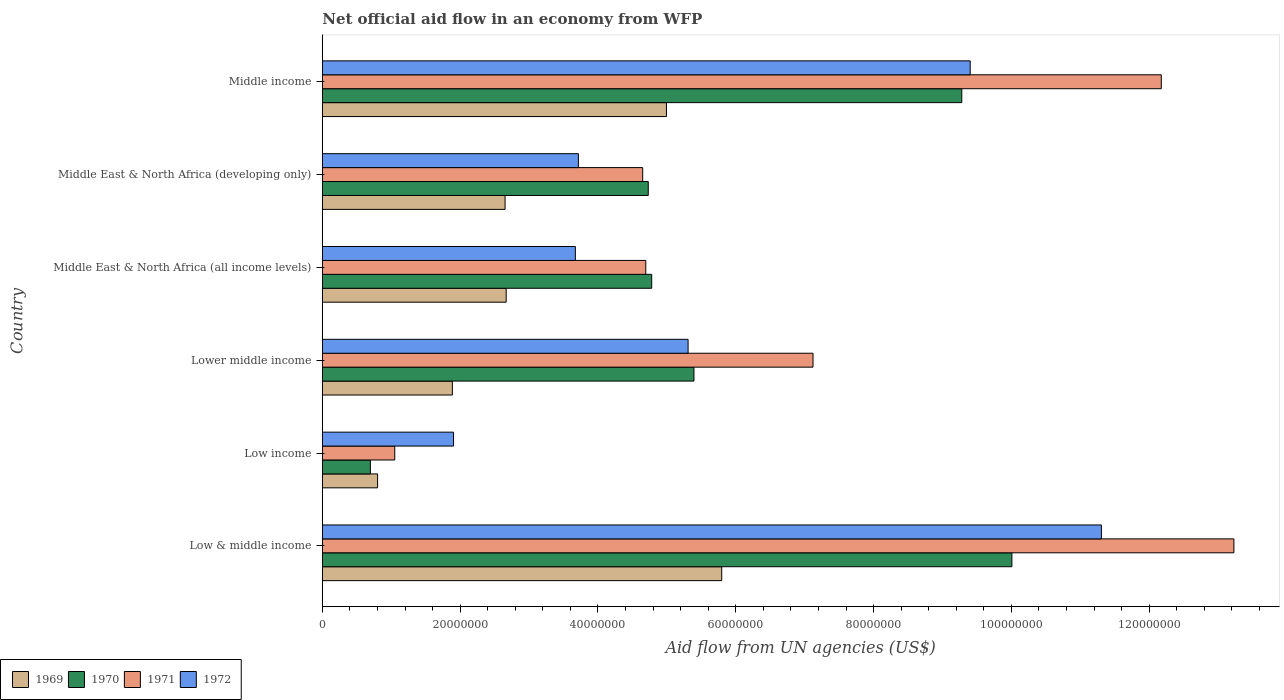How many different coloured bars are there?
Ensure brevity in your answer.  4. Are the number of bars on each tick of the Y-axis equal?
Make the answer very short. Yes. What is the net official aid flow in 1970 in Middle East & North Africa (all income levels)?
Keep it short and to the point. 4.78e+07. Across all countries, what is the maximum net official aid flow in 1972?
Provide a succinct answer. 1.13e+08. Across all countries, what is the minimum net official aid flow in 1970?
Give a very brief answer. 6.97e+06. In which country was the net official aid flow in 1971 maximum?
Provide a short and direct response. Low & middle income. In which country was the net official aid flow in 1972 minimum?
Ensure brevity in your answer.  Low income. What is the total net official aid flow in 1969 in the graph?
Your response must be concise. 1.88e+08. What is the difference between the net official aid flow in 1969 in Low & middle income and that in Low income?
Ensure brevity in your answer.  4.99e+07. What is the difference between the net official aid flow in 1972 in Middle income and the net official aid flow in 1970 in Low income?
Offer a very short reply. 8.70e+07. What is the average net official aid flow in 1972 per country?
Your response must be concise. 5.88e+07. What is the difference between the net official aid flow in 1972 and net official aid flow in 1971 in Middle East & North Africa (developing only)?
Ensure brevity in your answer.  -9.33e+06. What is the ratio of the net official aid flow in 1971 in Middle East & North Africa (all income levels) to that in Middle East & North Africa (developing only)?
Offer a terse response. 1.01. What is the difference between the highest and the second highest net official aid flow in 1972?
Your answer should be compact. 1.90e+07. What is the difference between the highest and the lowest net official aid flow in 1972?
Ensure brevity in your answer.  9.40e+07. Is the sum of the net official aid flow in 1972 in Low & middle income and Middle East & North Africa (all income levels) greater than the maximum net official aid flow in 1970 across all countries?
Keep it short and to the point. Yes. Is it the case that in every country, the sum of the net official aid flow in 1972 and net official aid flow in 1970 is greater than the sum of net official aid flow in 1971 and net official aid flow in 1969?
Offer a terse response. No. What does the 1st bar from the top in Low & middle income represents?
Offer a very short reply. 1972. What does the 3rd bar from the bottom in Lower middle income represents?
Provide a succinct answer. 1971. Is it the case that in every country, the sum of the net official aid flow in 1969 and net official aid flow in 1972 is greater than the net official aid flow in 1971?
Provide a short and direct response. Yes. How many countries are there in the graph?
Give a very brief answer. 6. Are the values on the major ticks of X-axis written in scientific E-notation?
Provide a succinct answer. No. Does the graph contain any zero values?
Make the answer very short. No. Where does the legend appear in the graph?
Ensure brevity in your answer.  Bottom left. How are the legend labels stacked?
Your response must be concise. Horizontal. What is the title of the graph?
Provide a succinct answer. Net official aid flow in an economy from WFP. What is the label or title of the X-axis?
Make the answer very short. Aid flow from UN agencies (US$). What is the label or title of the Y-axis?
Ensure brevity in your answer.  Country. What is the Aid flow from UN agencies (US$) of 1969 in Low & middle income?
Provide a short and direct response. 5.80e+07. What is the Aid flow from UN agencies (US$) of 1970 in Low & middle income?
Your response must be concise. 1.00e+08. What is the Aid flow from UN agencies (US$) in 1971 in Low & middle income?
Give a very brief answer. 1.32e+08. What is the Aid flow from UN agencies (US$) of 1972 in Low & middle income?
Keep it short and to the point. 1.13e+08. What is the Aid flow from UN agencies (US$) of 1969 in Low income?
Your answer should be compact. 8.02e+06. What is the Aid flow from UN agencies (US$) in 1970 in Low income?
Ensure brevity in your answer.  6.97e+06. What is the Aid flow from UN agencies (US$) of 1971 in Low income?
Keep it short and to the point. 1.05e+07. What is the Aid flow from UN agencies (US$) in 1972 in Low income?
Keep it short and to the point. 1.90e+07. What is the Aid flow from UN agencies (US$) in 1969 in Lower middle income?
Offer a terse response. 1.89e+07. What is the Aid flow from UN agencies (US$) in 1970 in Lower middle income?
Keep it short and to the point. 5.39e+07. What is the Aid flow from UN agencies (US$) in 1971 in Lower middle income?
Ensure brevity in your answer.  7.12e+07. What is the Aid flow from UN agencies (US$) of 1972 in Lower middle income?
Provide a succinct answer. 5.31e+07. What is the Aid flow from UN agencies (US$) in 1969 in Middle East & North Africa (all income levels)?
Ensure brevity in your answer.  2.67e+07. What is the Aid flow from UN agencies (US$) in 1970 in Middle East & North Africa (all income levels)?
Your answer should be compact. 4.78e+07. What is the Aid flow from UN agencies (US$) of 1971 in Middle East & North Africa (all income levels)?
Offer a very short reply. 4.69e+07. What is the Aid flow from UN agencies (US$) of 1972 in Middle East & North Africa (all income levels)?
Keep it short and to the point. 3.67e+07. What is the Aid flow from UN agencies (US$) of 1969 in Middle East & North Africa (developing only)?
Give a very brief answer. 2.65e+07. What is the Aid flow from UN agencies (US$) in 1970 in Middle East & North Africa (developing only)?
Provide a succinct answer. 4.73e+07. What is the Aid flow from UN agencies (US$) of 1971 in Middle East & North Africa (developing only)?
Offer a very short reply. 4.65e+07. What is the Aid flow from UN agencies (US$) of 1972 in Middle East & North Africa (developing only)?
Make the answer very short. 3.72e+07. What is the Aid flow from UN agencies (US$) of 1969 in Middle income?
Offer a terse response. 4.99e+07. What is the Aid flow from UN agencies (US$) of 1970 in Middle income?
Give a very brief answer. 9.28e+07. What is the Aid flow from UN agencies (US$) of 1971 in Middle income?
Keep it short and to the point. 1.22e+08. What is the Aid flow from UN agencies (US$) in 1972 in Middle income?
Offer a terse response. 9.40e+07. Across all countries, what is the maximum Aid flow from UN agencies (US$) of 1969?
Keep it short and to the point. 5.80e+07. Across all countries, what is the maximum Aid flow from UN agencies (US$) of 1970?
Your answer should be compact. 1.00e+08. Across all countries, what is the maximum Aid flow from UN agencies (US$) of 1971?
Your answer should be very brief. 1.32e+08. Across all countries, what is the maximum Aid flow from UN agencies (US$) of 1972?
Provide a succinct answer. 1.13e+08. Across all countries, what is the minimum Aid flow from UN agencies (US$) of 1969?
Offer a very short reply. 8.02e+06. Across all countries, what is the minimum Aid flow from UN agencies (US$) of 1970?
Give a very brief answer. 6.97e+06. Across all countries, what is the minimum Aid flow from UN agencies (US$) in 1971?
Your answer should be very brief. 1.05e+07. Across all countries, what is the minimum Aid flow from UN agencies (US$) of 1972?
Provide a short and direct response. 1.90e+07. What is the total Aid flow from UN agencies (US$) of 1969 in the graph?
Keep it short and to the point. 1.88e+08. What is the total Aid flow from UN agencies (US$) of 1970 in the graph?
Your response must be concise. 3.49e+08. What is the total Aid flow from UN agencies (US$) in 1971 in the graph?
Keep it short and to the point. 4.29e+08. What is the total Aid flow from UN agencies (US$) of 1972 in the graph?
Offer a terse response. 3.53e+08. What is the difference between the Aid flow from UN agencies (US$) of 1969 in Low & middle income and that in Low income?
Offer a very short reply. 4.99e+07. What is the difference between the Aid flow from UN agencies (US$) of 1970 in Low & middle income and that in Low income?
Keep it short and to the point. 9.31e+07. What is the difference between the Aid flow from UN agencies (US$) of 1971 in Low & middle income and that in Low income?
Your response must be concise. 1.22e+08. What is the difference between the Aid flow from UN agencies (US$) of 1972 in Low & middle income and that in Low income?
Provide a succinct answer. 9.40e+07. What is the difference between the Aid flow from UN agencies (US$) of 1969 in Low & middle income and that in Lower middle income?
Offer a very short reply. 3.91e+07. What is the difference between the Aid flow from UN agencies (US$) of 1970 in Low & middle income and that in Lower middle income?
Keep it short and to the point. 4.61e+07. What is the difference between the Aid flow from UN agencies (US$) of 1971 in Low & middle income and that in Lower middle income?
Your answer should be compact. 6.11e+07. What is the difference between the Aid flow from UN agencies (US$) in 1972 in Low & middle income and that in Lower middle income?
Your answer should be compact. 6.00e+07. What is the difference between the Aid flow from UN agencies (US$) of 1969 in Low & middle income and that in Middle East & North Africa (all income levels)?
Your answer should be very brief. 3.13e+07. What is the difference between the Aid flow from UN agencies (US$) in 1970 in Low & middle income and that in Middle East & North Africa (all income levels)?
Your response must be concise. 5.23e+07. What is the difference between the Aid flow from UN agencies (US$) in 1971 in Low & middle income and that in Middle East & North Africa (all income levels)?
Ensure brevity in your answer.  8.54e+07. What is the difference between the Aid flow from UN agencies (US$) of 1972 in Low & middle income and that in Middle East & North Africa (all income levels)?
Offer a terse response. 7.63e+07. What is the difference between the Aid flow from UN agencies (US$) in 1969 in Low & middle income and that in Middle East & North Africa (developing only)?
Offer a terse response. 3.14e+07. What is the difference between the Aid flow from UN agencies (US$) in 1970 in Low & middle income and that in Middle East & North Africa (developing only)?
Provide a succinct answer. 5.28e+07. What is the difference between the Aid flow from UN agencies (US$) in 1971 in Low & middle income and that in Middle East & North Africa (developing only)?
Offer a terse response. 8.58e+07. What is the difference between the Aid flow from UN agencies (US$) in 1972 in Low & middle income and that in Middle East & North Africa (developing only)?
Keep it short and to the point. 7.59e+07. What is the difference between the Aid flow from UN agencies (US$) in 1969 in Low & middle income and that in Middle income?
Provide a succinct answer. 8.02e+06. What is the difference between the Aid flow from UN agencies (US$) of 1970 in Low & middle income and that in Middle income?
Keep it short and to the point. 7.27e+06. What is the difference between the Aid flow from UN agencies (US$) in 1971 in Low & middle income and that in Middle income?
Your answer should be compact. 1.05e+07. What is the difference between the Aid flow from UN agencies (US$) in 1972 in Low & middle income and that in Middle income?
Provide a short and direct response. 1.90e+07. What is the difference between the Aid flow from UN agencies (US$) of 1969 in Low income and that in Lower middle income?
Your answer should be very brief. -1.08e+07. What is the difference between the Aid flow from UN agencies (US$) in 1970 in Low income and that in Lower middle income?
Offer a terse response. -4.70e+07. What is the difference between the Aid flow from UN agencies (US$) in 1971 in Low income and that in Lower middle income?
Your answer should be very brief. -6.07e+07. What is the difference between the Aid flow from UN agencies (US$) in 1972 in Low income and that in Lower middle income?
Your response must be concise. -3.40e+07. What is the difference between the Aid flow from UN agencies (US$) in 1969 in Low income and that in Middle East & North Africa (all income levels)?
Offer a terse response. -1.87e+07. What is the difference between the Aid flow from UN agencies (US$) of 1970 in Low income and that in Middle East & North Africa (all income levels)?
Ensure brevity in your answer.  -4.08e+07. What is the difference between the Aid flow from UN agencies (US$) of 1971 in Low income and that in Middle East & North Africa (all income levels)?
Give a very brief answer. -3.64e+07. What is the difference between the Aid flow from UN agencies (US$) of 1972 in Low income and that in Middle East & North Africa (all income levels)?
Provide a succinct answer. -1.77e+07. What is the difference between the Aid flow from UN agencies (US$) of 1969 in Low income and that in Middle East & North Africa (developing only)?
Your response must be concise. -1.85e+07. What is the difference between the Aid flow from UN agencies (US$) of 1970 in Low income and that in Middle East & North Africa (developing only)?
Make the answer very short. -4.03e+07. What is the difference between the Aid flow from UN agencies (US$) in 1971 in Low income and that in Middle East & North Africa (developing only)?
Give a very brief answer. -3.60e+07. What is the difference between the Aid flow from UN agencies (US$) in 1972 in Low income and that in Middle East & North Africa (developing only)?
Keep it short and to the point. -1.81e+07. What is the difference between the Aid flow from UN agencies (US$) in 1969 in Low income and that in Middle income?
Ensure brevity in your answer.  -4.19e+07. What is the difference between the Aid flow from UN agencies (US$) of 1970 in Low income and that in Middle income?
Make the answer very short. -8.58e+07. What is the difference between the Aid flow from UN agencies (US$) of 1971 in Low income and that in Middle income?
Offer a terse response. -1.11e+08. What is the difference between the Aid flow from UN agencies (US$) of 1972 in Low income and that in Middle income?
Offer a terse response. -7.50e+07. What is the difference between the Aid flow from UN agencies (US$) in 1969 in Lower middle income and that in Middle East & North Africa (all income levels)?
Ensure brevity in your answer.  -7.81e+06. What is the difference between the Aid flow from UN agencies (US$) in 1970 in Lower middle income and that in Middle East & North Africa (all income levels)?
Your answer should be very brief. 6.13e+06. What is the difference between the Aid flow from UN agencies (US$) in 1971 in Lower middle income and that in Middle East & North Africa (all income levels)?
Offer a very short reply. 2.43e+07. What is the difference between the Aid flow from UN agencies (US$) of 1972 in Lower middle income and that in Middle East & North Africa (all income levels)?
Offer a terse response. 1.64e+07. What is the difference between the Aid flow from UN agencies (US$) in 1969 in Lower middle income and that in Middle East & North Africa (developing only)?
Provide a short and direct response. -7.65e+06. What is the difference between the Aid flow from UN agencies (US$) of 1970 in Lower middle income and that in Middle East & North Africa (developing only)?
Give a very brief answer. 6.63e+06. What is the difference between the Aid flow from UN agencies (US$) in 1971 in Lower middle income and that in Middle East & North Africa (developing only)?
Your response must be concise. 2.47e+07. What is the difference between the Aid flow from UN agencies (US$) of 1972 in Lower middle income and that in Middle East & North Africa (developing only)?
Provide a succinct answer. 1.59e+07. What is the difference between the Aid flow from UN agencies (US$) in 1969 in Lower middle income and that in Middle income?
Ensure brevity in your answer.  -3.11e+07. What is the difference between the Aid flow from UN agencies (US$) in 1970 in Lower middle income and that in Middle income?
Your answer should be very brief. -3.89e+07. What is the difference between the Aid flow from UN agencies (US$) of 1971 in Lower middle income and that in Middle income?
Offer a very short reply. -5.05e+07. What is the difference between the Aid flow from UN agencies (US$) of 1972 in Lower middle income and that in Middle income?
Give a very brief answer. -4.09e+07. What is the difference between the Aid flow from UN agencies (US$) in 1970 in Middle East & North Africa (all income levels) and that in Middle East & North Africa (developing only)?
Give a very brief answer. 5.00e+05. What is the difference between the Aid flow from UN agencies (US$) in 1971 in Middle East & North Africa (all income levels) and that in Middle East & North Africa (developing only)?
Keep it short and to the point. 4.50e+05. What is the difference between the Aid flow from UN agencies (US$) of 1972 in Middle East & North Africa (all income levels) and that in Middle East & North Africa (developing only)?
Offer a very short reply. -4.40e+05. What is the difference between the Aid flow from UN agencies (US$) in 1969 in Middle East & North Africa (all income levels) and that in Middle income?
Provide a short and direct response. -2.33e+07. What is the difference between the Aid flow from UN agencies (US$) of 1970 in Middle East & North Africa (all income levels) and that in Middle income?
Keep it short and to the point. -4.50e+07. What is the difference between the Aid flow from UN agencies (US$) of 1971 in Middle East & North Africa (all income levels) and that in Middle income?
Your answer should be very brief. -7.48e+07. What is the difference between the Aid flow from UN agencies (US$) of 1972 in Middle East & North Africa (all income levels) and that in Middle income?
Provide a short and direct response. -5.73e+07. What is the difference between the Aid flow from UN agencies (US$) of 1969 in Middle East & North Africa (developing only) and that in Middle income?
Offer a very short reply. -2.34e+07. What is the difference between the Aid flow from UN agencies (US$) in 1970 in Middle East & North Africa (developing only) and that in Middle income?
Make the answer very short. -4.55e+07. What is the difference between the Aid flow from UN agencies (US$) of 1971 in Middle East & North Africa (developing only) and that in Middle income?
Offer a very short reply. -7.53e+07. What is the difference between the Aid flow from UN agencies (US$) in 1972 in Middle East & North Africa (developing only) and that in Middle income?
Your answer should be compact. -5.69e+07. What is the difference between the Aid flow from UN agencies (US$) in 1969 in Low & middle income and the Aid flow from UN agencies (US$) in 1970 in Low income?
Provide a short and direct response. 5.10e+07. What is the difference between the Aid flow from UN agencies (US$) of 1969 in Low & middle income and the Aid flow from UN agencies (US$) of 1971 in Low income?
Your response must be concise. 4.74e+07. What is the difference between the Aid flow from UN agencies (US$) of 1969 in Low & middle income and the Aid flow from UN agencies (US$) of 1972 in Low income?
Provide a succinct answer. 3.89e+07. What is the difference between the Aid flow from UN agencies (US$) in 1970 in Low & middle income and the Aid flow from UN agencies (US$) in 1971 in Low income?
Ensure brevity in your answer.  8.96e+07. What is the difference between the Aid flow from UN agencies (US$) in 1970 in Low & middle income and the Aid flow from UN agencies (US$) in 1972 in Low income?
Your answer should be very brief. 8.10e+07. What is the difference between the Aid flow from UN agencies (US$) in 1971 in Low & middle income and the Aid flow from UN agencies (US$) in 1972 in Low income?
Give a very brief answer. 1.13e+08. What is the difference between the Aid flow from UN agencies (US$) of 1969 in Low & middle income and the Aid flow from UN agencies (US$) of 1970 in Lower middle income?
Make the answer very short. 4.03e+06. What is the difference between the Aid flow from UN agencies (US$) of 1969 in Low & middle income and the Aid flow from UN agencies (US$) of 1971 in Lower middle income?
Offer a terse response. -1.32e+07. What is the difference between the Aid flow from UN agencies (US$) in 1969 in Low & middle income and the Aid flow from UN agencies (US$) in 1972 in Lower middle income?
Your answer should be very brief. 4.88e+06. What is the difference between the Aid flow from UN agencies (US$) of 1970 in Low & middle income and the Aid flow from UN agencies (US$) of 1971 in Lower middle income?
Keep it short and to the point. 2.89e+07. What is the difference between the Aid flow from UN agencies (US$) of 1970 in Low & middle income and the Aid flow from UN agencies (US$) of 1972 in Lower middle income?
Your response must be concise. 4.70e+07. What is the difference between the Aid flow from UN agencies (US$) in 1971 in Low & middle income and the Aid flow from UN agencies (US$) in 1972 in Lower middle income?
Offer a very short reply. 7.92e+07. What is the difference between the Aid flow from UN agencies (US$) of 1969 in Low & middle income and the Aid flow from UN agencies (US$) of 1970 in Middle East & North Africa (all income levels)?
Your answer should be very brief. 1.02e+07. What is the difference between the Aid flow from UN agencies (US$) in 1969 in Low & middle income and the Aid flow from UN agencies (US$) in 1971 in Middle East & North Africa (all income levels)?
Your answer should be very brief. 1.10e+07. What is the difference between the Aid flow from UN agencies (US$) in 1969 in Low & middle income and the Aid flow from UN agencies (US$) in 1972 in Middle East & North Africa (all income levels)?
Your response must be concise. 2.12e+07. What is the difference between the Aid flow from UN agencies (US$) in 1970 in Low & middle income and the Aid flow from UN agencies (US$) in 1971 in Middle East & North Africa (all income levels)?
Keep it short and to the point. 5.31e+07. What is the difference between the Aid flow from UN agencies (US$) of 1970 in Low & middle income and the Aid flow from UN agencies (US$) of 1972 in Middle East & North Africa (all income levels)?
Offer a very short reply. 6.34e+07. What is the difference between the Aid flow from UN agencies (US$) of 1971 in Low & middle income and the Aid flow from UN agencies (US$) of 1972 in Middle East & North Africa (all income levels)?
Offer a very short reply. 9.56e+07. What is the difference between the Aid flow from UN agencies (US$) in 1969 in Low & middle income and the Aid flow from UN agencies (US$) in 1970 in Middle East & North Africa (developing only)?
Keep it short and to the point. 1.07e+07. What is the difference between the Aid flow from UN agencies (US$) in 1969 in Low & middle income and the Aid flow from UN agencies (US$) in 1971 in Middle East & North Africa (developing only)?
Your answer should be very brief. 1.15e+07. What is the difference between the Aid flow from UN agencies (US$) of 1969 in Low & middle income and the Aid flow from UN agencies (US$) of 1972 in Middle East & North Africa (developing only)?
Provide a short and direct response. 2.08e+07. What is the difference between the Aid flow from UN agencies (US$) of 1970 in Low & middle income and the Aid flow from UN agencies (US$) of 1971 in Middle East & North Africa (developing only)?
Provide a short and direct response. 5.36e+07. What is the difference between the Aid flow from UN agencies (US$) in 1970 in Low & middle income and the Aid flow from UN agencies (US$) in 1972 in Middle East & North Africa (developing only)?
Keep it short and to the point. 6.29e+07. What is the difference between the Aid flow from UN agencies (US$) of 1971 in Low & middle income and the Aid flow from UN agencies (US$) of 1972 in Middle East & North Africa (developing only)?
Keep it short and to the point. 9.51e+07. What is the difference between the Aid flow from UN agencies (US$) in 1969 in Low & middle income and the Aid flow from UN agencies (US$) in 1970 in Middle income?
Your answer should be very brief. -3.48e+07. What is the difference between the Aid flow from UN agencies (US$) in 1969 in Low & middle income and the Aid flow from UN agencies (US$) in 1971 in Middle income?
Your response must be concise. -6.38e+07. What is the difference between the Aid flow from UN agencies (US$) in 1969 in Low & middle income and the Aid flow from UN agencies (US$) in 1972 in Middle income?
Provide a succinct answer. -3.61e+07. What is the difference between the Aid flow from UN agencies (US$) of 1970 in Low & middle income and the Aid flow from UN agencies (US$) of 1971 in Middle income?
Offer a very short reply. -2.17e+07. What is the difference between the Aid flow from UN agencies (US$) in 1970 in Low & middle income and the Aid flow from UN agencies (US$) in 1972 in Middle income?
Ensure brevity in your answer.  6.05e+06. What is the difference between the Aid flow from UN agencies (US$) in 1971 in Low & middle income and the Aid flow from UN agencies (US$) in 1972 in Middle income?
Provide a succinct answer. 3.83e+07. What is the difference between the Aid flow from UN agencies (US$) of 1969 in Low income and the Aid flow from UN agencies (US$) of 1970 in Lower middle income?
Provide a succinct answer. -4.59e+07. What is the difference between the Aid flow from UN agencies (US$) in 1969 in Low income and the Aid flow from UN agencies (US$) in 1971 in Lower middle income?
Provide a succinct answer. -6.32e+07. What is the difference between the Aid flow from UN agencies (US$) of 1969 in Low income and the Aid flow from UN agencies (US$) of 1972 in Lower middle income?
Your answer should be compact. -4.51e+07. What is the difference between the Aid flow from UN agencies (US$) in 1970 in Low income and the Aid flow from UN agencies (US$) in 1971 in Lower middle income?
Provide a succinct answer. -6.42e+07. What is the difference between the Aid flow from UN agencies (US$) of 1970 in Low income and the Aid flow from UN agencies (US$) of 1972 in Lower middle income?
Your answer should be compact. -4.61e+07. What is the difference between the Aid flow from UN agencies (US$) in 1971 in Low income and the Aid flow from UN agencies (US$) in 1972 in Lower middle income?
Offer a terse response. -4.26e+07. What is the difference between the Aid flow from UN agencies (US$) in 1969 in Low income and the Aid flow from UN agencies (US$) in 1970 in Middle East & North Africa (all income levels)?
Provide a succinct answer. -3.98e+07. What is the difference between the Aid flow from UN agencies (US$) of 1969 in Low income and the Aid flow from UN agencies (US$) of 1971 in Middle East & North Africa (all income levels)?
Your answer should be compact. -3.89e+07. What is the difference between the Aid flow from UN agencies (US$) of 1969 in Low income and the Aid flow from UN agencies (US$) of 1972 in Middle East & North Africa (all income levels)?
Your answer should be compact. -2.87e+07. What is the difference between the Aid flow from UN agencies (US$) in 1970 in Low income and the Aid flow from UN agencies (US$) in 1971 in Middle East & North Africa (all income levels)?
Your answer should be compact. -4.00e+07. What is the difference between the Aid flow from UN agencies (US$) in 1970 in Low income and the Aid flow from UN agencies (US$) in 1972 in Middle East & North Africa (all income levels)?
Offer a terse response. -2.98e+07. What is the difference between the Aid flow from UN agencies (US$) of 1971 in Low income and the Aid flow from UN agencies (US$) of 1972 in Middle East & North Africa (all income levels)?
Your response must be concise. -2.62e+07. What is the difference between the Aid flow from UN agencies (US$) of 1969 in Low income and the Aid flow from UN agencies (US$) of 1970 in Middle East & North Africa (developing only)?
Keep it short and to the point. -3.93e+07. What is the difference between the Aid flow from UN agencies (US$) of 1969 in Low income and the Aid flow from UN agencies (US$) of 1971 in Middle East & North Africa (developing only)?
Your answer should be very brief. -3.85e+07. What is the difference between the Aid flow from UN agencies (US$) of 1969 in Low income and the Aid flow from UN agencies (US$) of 1972 in Middle East & North Africa (developing only)?
Your answer should be very brief. -2.91e+07. What is the difference between the Aid flow from UN agencies (US$) in 1970 in Low income and the Aid flow from UN agencies (US$) in 1971 in Middle East & North Africa (developing only)?
Keep it short and to the point. -3.95e+07. What is the difference between the Aid flow from UN agencies (US$) of 1970 in Low income and the Aid flow from UN agencies (US$) of 1972 in Middle East & North Africa (developing only)?
Provide a short and direct response. -3.02e+07. What is the difference between the Aid flow from UN agencies (US$) in 1971 in Low income and the Aid flow from UN agencies (US$) in 1972 in Middle East & North Africa (developing only)?
Provide a short and direct response. -2.66e+07. What is the difference between the Aid flow from UN agencies (US$) in 1969 in Low income and the Aid flow from UN agencies (US$) in 1970 in Middle income?
Provide a short and direct response. -8.48e+07. What is the difference between the Aid flow from UN agencies (US$) of 1969 in Low income and the Aid flow from UN agencies (US$) of 1971 in Middle income?
Ensure brevity in your answer.  -1.14e+08. What is the difference between the Aid flow from UN agencies (US$) of 1969 in Low income and the Aid flow from UN agencies (US$) of 1972 in Middle income?
Ensure brevity in your answer.  -8.60e+07. What is the difference between the Aid flow from UN agencies (US$) in 1970 in Low income and the Aid flow from UN agencies (US$) in 1971 in Middle income?
Offer a terse response. -1.15e+08. What is the difference between the Aid flow from UN agencies (US$) of 1970 in Low income and the Aid flow from UN agencies (US$) of 1972 in Middle income?
Ensure brevity in your answer.  -8.70e+07. What is the difference between the Aid flow from UN agencies (US$) in 1971 in Low income and the Aid flow from UN agencies (US$) in 1972 in Middle income?
Provide a succinct answer. -8.35e+07. What is the difference between the Aid flow from UN agencies (US$) of 1969 in Lower middle income and the Aid flow from UN agencies (US$) of 1970 in Middle East & North Africa (all income levels)?
Your response must be concise. -2.89e+07. What is the difference between the Aid flow from UN agencies (US$) in 1969 in Lower middle income and the Aid flow from UN agencies (US$) in 1971 in Middle East & North Africa (all income levels)?
Your answer should be compact. -2.81e+07. What is the difference between the Aid flow from UN agencies (US$) in 1969 in Lower middle income and the Aid flow from UN agencies (US$) in 1972 in Middle East & North Africa (all income levels)?
Give a very brief answer. -1.78e+07. What is the difference between the Aid flow from UN agencies (US$) in 1970 in Lower middle income and the Aid flow from UN agencies (US$) in 1971 in Middle East & North Africa (all income levels)?
Offer a terse response. 6.99e+06. What is the difference between the Aid flow from UN agencies (US$) of 1970 in Lower middle income and the Aid flow from UN agencies (US$) of 1972 in Middle East & North Africa (all income levels)?
Provide a succinct answer. 1.72e+07. What is the difference between the Aid flow from UN agencies (US$) in 1971 in Lower middle income and the Aid flow from UN agencies (US$) in 1972 in Middle East & North Africa (all income levels)?
Your response must be concise. 3.45e+07. What is the difference between the Aid flow from UN agencies (US$) in 1969 in Lower middle income and the Aid flow from UN agencies (US$) in 1970 in Middle East & North Africa (developing only)?
Provide a succinct answer. -2.84e+07. What is the difference between the Aid flow from UN agencies (US$) of 1969 in Lower middle income and the Aid flow from UN agencies (US$) of 1971 in Middle East & North Africa (developing only)?
Provide a succinct answer. -2.76e+07. What is the difference between the Aid flow from UN agencies (US$) in 1969 in Lower middle income and the Aid flow from UN agencies (US$) in 1972 in Middle East & North Africa (developing only)?
Provide a succinct answer. -1.83e+07. What is the difference between the Aid flow from UN agencies (US$) of 1970 in Lower middle income and the Aid flow from UN agencies (US$) of 1971 in Middle East & North Africa (developing only)?
Your answer should be compact. 7.44e+06. What is the difference between the Aid flow from UN agencies (US$) in 1970 in Lower middle income and the Aid flow from UN agencies (US$) in 1972 in Middle East & North Africa (developing only)?
Your response must be concise. 1.68e+07. What is the difference between the Aid flow from UN agencies (US$) in 1971 in Lower middle income and the Aid flow from UN agencies (US$) in 1972 in Middle East & North Africa (developing only)?
Ensure brevity in your answer.  3.40e+07. What is the difference between the Aid flow from UN agencies (US$) in 1969 in Lower middle income and the Aid flow from UN agencies (US$) in 1970 in Middle income?
Provide a short and direct response. -7.39e+07. What is the difference between the Aid flow from UN agencies (US$) in 1969 in Lower middle income and the Aid flow from UN agencies (US$) in 1971 in Middle income?
Offer a terse response. -1.03e+08. What is the difference between the Aid flow from UN agencies (US$) in 1969 in Lower middle income and the Aid flow from UN agencies (US$) in 1972 in Middle income?
Offer a very short reply. -7.52e+07. What is the difference between the Aid flow from UN agencies (US$) in 1970 in Lower middle income and the Aid flow from UN agencies (US$) in 1971 in Middle income?
Provide a succinct answer. -6.78e+07. What is the difference between the Aid flow from UN agencies (US$) in 1970 in Lower middle income and the Aid flow from UN agencies (US$) in 1972 in Middle income?
Offer a terse response. -4.01e+07. What is the difference between the Aid flow from UN agencies (US$) of 1971 in Lower middle income and the Aid flow from UN agencies (US$) of 1972 in Middle income?
Give a very brief answer. -2.28e+07. What is the difference between the Aid flow from UN agencies (US$) of 1969 in Middle East & North Africa (all income levels) and the Aid flow from UN agencies (US$) of 1970 in Middle East & North Africa (developing only)?
Offer a terse response. -2.06e+07. What is the difference between the Aid flow from UN agencies (US$) in 1969 in Middle East & North Africa (all income levels) and the Aid flow from UN agencies (US$) in 1971 in Middle East & North Africa (developing only)?
Offer a very short reply. -1.98e+07. What is the difference between the Aid flow from UN agencies (US$) in 1969 in Middle East & North Africa (all income levels) and the Aid flow from UN agencies (US$) in 1972 in Middle East & North Africa (developing only)?
Provide a succinct answer. -1.05e+07. What is the difference between the Aid flow from UN agencies (US$) in 1970 in Middle East & North Africa (all income levels) and the Aid flow from UN agencies (US$) in 1971 in Middle East & North Africa (developing only)?
Offer a terse response. 1.31e+06. What is the difference between the Aid flow from UN agencies (US$) in 1970 in Middle East & North Africa (all income levels) and the Aid flow from UN agencies (US$) in 1972 in Middle East & North Africa (developing only)?
Provide a succinct answer. 1.06e+07. What is the difference between the Aid flow from UN agencies (US$) of 1971 in Middle East & North Africa (all income levels) and the Aid flow from UN agencies (US$) of 1972 in Middle East & North Africa (developing only)?
Your response must be concise. 9.78e+06. What is the difference between the Aid flow from UN agencies (US$) of 1969 in Middle East & North Africa (all income levels) and the Aid flow from UN agencies (US$) of 1970 in Middle income?
Your answer should be very brief. -6.61e+07. What is the difference between the Aid flow from UN agencies (US$) of 1969 in Middle East & North Africa (all income levels) and the Aid flow from UN agencies (US$) of 1971 in Middle income?
Give a very brief answer. -9.51e+07. What is the difference between the Aid flow from UN agencies (US$) in 1969 in Middle East & North Africa (all income levels) and the Aid flow from UN agencies (US$) in 1972 in Middle income?
Keep it short and to the point. -6.73e+07. What is the difference between the Aid flow from UN agencies (US$) in 1970 in Middle East & North Africa (all income levels) and the Aid flow from UN agencies (US$) in 1971 in Middle income?
Provide a short and direct response. -7.40e+07. What is the difference between the Aid flow from UN agencies (US$) in 1970 in Middle East & North Africa (all income levels) and the Aid flow from UN agencies (US$) in 1972 in Middle income?
Keep it short and to the point. -4.62e+07. What is the difference between the Aid flow from UN agencies (US$) of 1971 in Middle East & North Africa (all income levels) and the Aid flow from UN agencies (US$) of 1972 in Middle income?
Provide a succinct answer. -4.71e+07. What is the difference between the Aid flow from UN agencies (US$) in 1969 in Middle East & North Africa (developing only) and the Aid flow from UN agencies (US$) in 1970 in Middle income?
Offer a very short reply. -6.63e+07. What is the difference between the Aid flow from UN agencies (US$) in 1969 in Middle East & North Africa (developing only) and the Aid flow from UN agencies (US$) in 1971 in Middle income?
Give a very brief answer. -9.52e+07. What is the difference between the Aid flow from UN agencies (US$) in 1969 in Middle East & North Africa (developing only) and the Aid flow from UN agencies (US$) in 1972 in Middle income?
Your answer should be very brief. -6.75e+07. What is the difference between the Aid flow from UN agencies (US$) of 1970 in Middle East & North Africa (developing only) and the Aid flow from UN agencies (US$) of 1971 in Middle income?
Provide a succinct answer. -7.44e+07. What is the difference between the Aid flow from UN agencies (US$) in 1970 in Middle East & North Africa (developing only) and the Aid flow from UN agencies (US$) in 1972 in Middle income?
Give a very brief answer. -4.67e+07. What is the difference between the Aid flow from UN agencies (US$) of 1971 in Middle East & North Africa (developing only) and the Aid flow from UN agencies (US$) of 1972 in Middle income?
Make the answer very short. -4.75e+07. What is the average Aid flow from UN agencies (US$) of 1969 per country?
Keep it short and to the point. 3.13e+07. What is the average Aid flow from UN agencies (US$) in 1970 per country?
Ensure brevity in your answer.  5.81e+07. What is the average Aid flow from UN agencies (US$) of 1971 per country?
Ensure brevity in your answer.  7.15e+07. What is the average Aid flow from UN agencies (US$) of 1972 per country?
Provide a short and direct response. 5.88e+07. What is the difference between the Aid flow from UN agencies (US$) in 1969 and Aid flow from UN agencies (US$) in 1970 in Low & middle income?
Your answer should be very brief. -4.21e+07. What is the difference between the Aid flow from UN agencies (US$) of 1969 and Aid flow from UN agencies (US$) of 1971 in Low & middle income?
Your answer should be compact. -7.43e+07. What is the difference between the Aid flow from UN agencies (US$) of 1969 and Aid flow from UN agencies (US$) of 1972 in Low & middle income?
Give a very brief answer. -5.51e+07. What is the difference between the Aid flow from UN agencies (US$) in 1970 and Aid flow from UN agencies (US$) in 1971 in Low & middle income?
Provide a short and direct response. -3.22e+07. What is the difference between the Aid flow from UN agencies (US$) in 1970 and Aid flow from UN agencies (US$) in 1972 in Low & middle income?
Provide a succinct answer. -1.30e+07. What is the difference between the Aid flow from UN agencies (US$) of 1971 and Aid flow from UN agencies (US$) of 1972 in Low & middle income?
Offer a terse response. 1.92e+07. What is the difference between the Aid flow from UN agencies (US$) of 1969 and Aid flow from UN agencies (US$) of 1970 in Low income?
Provide a succinct answer. 1.05e+06. What is the difference between the Aid flow from UN agencies (US$) in 1969 and Aid flow from UN agencies (US$) in 1971 in Low income?
Provide a succinct answer. -2.49e+06. What is the difference between the Aid flow from UN agencies (US$) in 1969 and Aid flow from UN agencies (US$) in 1972 in Low income?
Keep it short and to the point. -1.10e+07. What is the difference between the Aid flow from UN agencies (US$) in 1970 and Aid flow from UN agencies (US$) in 1971 in Low income?
Your answer should be very brief. -3.54e+06. What is the difference between the Aid flow from UN agencies (US$) in 1970 and Aid flow from UN agencies (US$) in 1972 in Low income?
Offer a terse response. -1.21e+07. What is the difference between the Aid flow from UN agencies (US$) in 1971 and Aid flow from UN agencies (US$) in 1972 in Low income?
Ensure brevity in your answer.  -8.53e+06. What is the difference between the Aid flow from UN agencies (US$) of 1969 and Aid flow from UN agencies (US$) of 1970 in Lower middle income?
Your answer should be very brief. -3.51e+07. What is the difference between the Aid flow from UN agencies (US$) in 1969 and Aid flow from UN agencies (US$) in 1971 in Lower middle income?
Provide a short and direct response. -5.23e+07. What is the difference between the Aid flow from UN agencies (US$) in 1969 and Aid flow from UN agencies (US$) in 1972 in Lower middle income?
Offer a very short reply. -3.42e+07. What is the difference between the Aid flow from UN agencies (US$) in 1970 and Aid flow from UN agencies (US$) in 1971 in Lower middle income?
Provide a succinct answer. -1.73e+07. What is the difference between the Aid flow from UN agencies (US$) of 1970 and Aid flow from UN agencies (US$) of 1972 in Lower middle income?
Ensure brevity in your answer.  8.50e+05. What is the difference between the Aid flow from UN agencies (US$) in 1971 and Aid flow from UN agencies (US$) in 1972 in Lower middle income?
Give a very brief answer. 1.81e+07. What is the difference between the Aid flow from UN agencies (US$) in 1969 and Aid flow from UN agencies (US$) in 1970 in Middle East & North Africa (all income levels)?
Your response must be concise. -2.11e+07. What is the difference between the Aid flow from UN agencies (US$) of 1969 and Aid flow from UN agencies (US$) of 1971 in Middle East & North Africa (all income levels)?
Ensure brevity in your answer.  -2.03e+07. What is the difference between the Aid flow from UN agencies (US$) in 1969 and Aid flow from UN agencies (US$) in 1972 in Middle East & North Africa (all income levels)?
Provide a short and direct response. -1.00e+07. What is the difference between the Aid flow from UN agencies (US$) in 1970 and Aid flow from UN agencies (US$) in 1971 in Middle East & North Africa (all income levels)?
Your response must be concise. 8.60e+05. What is the difference between the Aid flow from UN agencies (US$) of 1970 and Aid flow from UN agencies (US$) of 1972 in Middle East & North Africa (all income levels)?
Give a very brief answer. 1.11e+07. What is the difference between the Aid flow from UN agencies (US$) in 1971 and Aid flow from UN agencies (US$) in 1972 in Middle East & North Africa (all income levels)?
Offer a very short reply. 1.02e+07. What is the difference between the Aid flow from UN agencies (US$) in 1969 and Aid flow from UN agencies (US$) in 1970 in Middle East & North Africa (developing only)?
Your answer should be compact. -2.08e+07. What is the difference between the Aid flow from UN agencies (US$) in 1969 and Aid flow from UN agencies (US$) in 1971 in Middle East & North Africa (developing only)?
Provide a succinct answer. -2.00e+07. What is the difference between the Aid flow from UN agencies (US$) in 1969 and Aid flow from UN agencies (US$) in 1972 in Middle East & North Africa (developing only)?
Offer a terse response. -1.06e+07. What is the difference between the Aid flow from UN agencies (US$) of 1970 and Aid flow from UN agencies (US$) of 1971 in Middle East & North Africa (developing only)?
Provide a succinct answer. 8.10e+05. What is the difference between the Aid flow from UN agencies (US$) of 1970 and Aid flow from UN agencies (US$) of 1972 in Middle East & North Africa (developing only)?
Offer a terse response. 1.01e+07. What is the difference between the Aid flow from UN agencies (US$) in 1971 and Aid flow from UN agencies (US$) in 1972 in Middle East & North Africa (developing only)?
Provide a succinct answer. 9.33e+06. What is the difference between the Aid flow from UN agencies (US$) in 1969 and Aid flow from UN agencies (US$) in 1970 in Middle income?
Give a very brief answer. -4.29e+07. What is the difference between the Aid flow from UN agencies (US$) of 1969 and Aid flow from UN agencies (US$) of 1971 in Middle income?
Provide a short and direct response. -7.18e+07. What is the difference between the Aid flow from UN agencies (US$) of 1969 and Aid flow from UN agencies (US$) of 1972 in Middle income?
Offer a terse response. -4.41e+07. What is the difference between the Aid flow from UN agencies (US$) in 1970 and Aid flow from UN agencies (US$) in 1971 in Middle income?
Give a very brief answer. -2.90e+07. What is the difference between the Aid flow from UN agencies (US$) in 1970 and Aid flow from UN agencies (US$) in 1972 in Middle income?
Your answer should be compact. -1.22e+06. What is the difference between the Aid flow from UN agencies (US$) of 1971 and Aid flow from UN agencies (US$) of 1972 in Middle income?
Offer a terse response. 2.77e+07. What is the ratio of the Aid flow from UN agencies (US$) in 1969 in Low & middle income to that in Low income?
Make the answer very short. 7.23. What is the ratio of the Aid flow from UN agencies (US$) of 1970 in Low & middle income to that in Low income?
Make the answer very short. 14.36. What is the ratio of the Aid flow from UN agencies (US$) of 1971 in Low & middle income to that in Low income?
Give a very brief answer. 12.59. What is the ratio of the Aid flow from UN agencies (US$) in 1972 in Low & middle income to that in Low income?
Offer a terse response. 5.94. What is the ratio of the Aid flow from UN agencies (US$) of 1969 in Low & middle income to that in Lower middle income?
Keep it short and to the point. 3.07. What is the ratio of the Aid flow from UN agencies (US$) of 1970 in Low & middle income to that in Lower middle income?
Your answer should be very brief. 1.86. What is the ratio of the Aid flow from UN agencies (US$) of 1971 in Low & middle income to that in Lower middle income?
Give a very brief answer. 1.86. What is the ratio of the Aid flow from UN agencies (US$) of 1972 in Low & middle income to that in Lower middle income?
Keep it short and to the point. 2.13. What is the ratio of the Aid flow from UN agencies (US$) of 1969 in Low & middle income to that in Middle East & North Africa (all income levels)?
Your answer should be very brief. 2.17. What is the ratio of the Aid flow from UN agencies (US$) in 1970 in Low & middle income to that in Middle East & North Africa (all income levels)?
Keep it short and to the point. 2.09. What is the ratio of the Aid flow from UN agencies (US$) of 1971 in Low & middle income to that in Middle East & North Africa (all income levels)?
Provide a succinct answer. 2.82. What is the ratio of the Aid flow from UN agencies (US$) in 1972 in Low & middle income to that in Middle East & North Africa (all income levels)?
Provide a succinct answer. 3.08. What is the ratio of the Aid flow from UN agencies (US$) in 1969 in Low & middle income to that in Middle East & North Africa (developing only)?
Offer a very short reply. 2.19. What is the ratio of the Aid flow from UN agencies (US$) of 1970 in Low & middle income to that in Middle East & North Africa (developing only)?
Provide a succinct answer. 2.12. What is the ratio of the Aid flow from UN agencies (US$) in 1971 in Low & middle income to that in Middle East & North Africa (developing only)?
Offer a very short reply. 2.85. What is the ratio of the Aid flow from UN agencies (US$) of 1972 in Low & middle income to that in Middle East & North Africa (developing only)?
Offer a terse response. 3.04. What is the ratio of the Aid flow from UN agencies (US$) in 1969 in Low & middle income to that in Middle income?
Your response must be concise. 1.16. What is the ratio of the Aid flow from UN agencies (US$) of 1970 in Low & middle income to that in Middle income?
Provide a short and direct response. 1.08. What is the ratio of the Aid flow from UN agencies (US$) in 1971 in Low & middle income to that in Middle income?
Your response must be concise. 1.09. What is the ratio of the Aid flow from UN agencies (US$) of 1972 in Low & middle income to that in Middle income?
Ensure brevity in your answer.  1.2. What is the ratio of the Aid flow from UN agencies (US$) in 1969 in Low income to that in Lower middle income?
Give a very brief answer. 0.42. What is the ratio of the Aid flow from UN agencies (US$) in 1970 in Low income to that in Lower middle income?
Keep it short and to the point. 0.13. What is the ratio of the Aid flow from UN agencies (US$) in 1971 in Low income to that in Lower middle income?
Offer a very short reply. 0.15. What is the ratio of the Aid flow from UN agencies (US$) in 1972 in Low income to that in Lower middle income?
Keep it short and to the point. 0.36. What is the ratio of the Aid flow from UN agencies (US$) in 1969 in Low income to that in Middle East & North Africa (all income levels)?
Keep it short and to the point. 0.3. What is the ratio of the Aid flow from UN agencies (US$) of 1970 in Low income to that in Middle East & North Africa (all income levels)?
Ensure brevity in your answer.  0.15. What is the ratio of the Aid flow from UN agencies (US$) in 1971 in Low income to that in Middle East & North Africa (all income levels)?
Your answer should be compact. 0.22. What is the ratio of the Aid flow from UN agencies (US$) in 1972 in Low income to that in Middle East & North Africa (all income levels)?
Your answer should be very brief. 0.52. What is the ratio of the Aid flow from UN agencies (US$) in 1969 in Low income to that in Middle East & North Africa (developing only)?
Provide a succinct answer. 0.3. What is the ratio of the Aid flow from UN agencies (US$) in 1970 in Low income to that in Middle East & North Africa (developing only)?
Offer a terse response. 0.15. What is the ratio of the Aid flow from UN agencies (US$) of 1971 in Low income to that in Middle East & North Africa (developing only)?
Your answer should be compact. 0.23. What is the ratio of the Aid flow from UN agencies (US$) of 1972 in Low income to that in Middle East & North Africa (developing only)?
Your answer should be very brief. 0.51. What is the ratio of the Aid flow from UN agencies (US$) of 1969 in Low income to that in Middle income?
Offer a terse response. 0.16. What is the ratio of the Aid flow from UN agencies (US$) in 1970 in Low income to that in Middle income?
Make the answer very short. 0.08. What is the ratio of the Aid flow from UN agencies (US$) of 1971 in Low income to that in Middle income?
Give a very brief answer. 0.09. What is the ratio of the Aid flow from UN agencies (US$) of 1972 in Low income to that in Middle income?
Ensure brevity in your answer.  0.2. What is the ratio of the Aid flow from UN agencies (US$) of 1969 in Lower middle income to that in Middle East & North Africa (all income levels)?
Your response must be concise. 0.71. What is the ratio of the Aid flow from UN agencies (US$) in 1970 in Lower middle income to that in Middle East & North Africa (all income levels)?
Your answer should be compact. 1.13. What is the ratio of the Aid flow from UN agencies (US$) in 1971 in Lower middle income to that in Middle East & North Africa (all income levels)?
Your response must be concise. 1.52. What is the ratio of the Aid flow from UN agencies (US$) of 1972 in Lower middle income to that in Middle East & North Africa (all income levels)?
Your answer should be very brief. 1.45. What is the ratio of the Aid flow from UN agencies (US$) of 1969 in Lower middle income to that in Middle East & North Africa (developing only)?
Your response must be concise. 0.71. What is the ratio of the Aid flow from UN agencies (US$) in 1970 in Lower middle income to that in Middle East & North Africa (developing only)?
Offer a very short reply. 1.14. What is the ratio of the Aid flow from UN agencies (US$) of 1971 in Lower middle income to that in Middle East & North Africa (developing only)?
Your response must be concise. 1.53. What is the ratio of the Aid flow from UN agencies (US$) of 1972 in Lower middle income to that in Middle East & North Africa (developing only)?
Provide a short and direct response. 1.43. What is the ratio of the Aid flow from UN agencies (US$) in 1969 in Lower middle income to that in Middle income?
Give a very brief answer. 0.38. What is the ratio of the Aid flow from UN agencies (US$) of 1970 in Lower middle income to that in Middle income?
Give a very brief answer. 0.58. What is the ratio of the Aid flow from UN agencies (US$) of 1971 in Lower middle income to that in Middle income?
Offer a very short reply. 0.58. What is the ratio of the Aid flow from UN agencies (US$) of 1972 in Lower middle income to that in Middle income?
Ensure brevity in your answer.  0.56. What is the ratio of the Aid flow from UN agencies (US$) of 1969 in Middle East & North Africa (all income levels) to that in Middle East & North Africa (developing only)?
Make the answer very short. 1.01. What is the ratio of the Aid flow from UN agencies (US$) in 1970 in Middle East & North Africa (all income levels) to that in Middle East & North Africa (developing only)?
Give a very brief answer. 1.01. What is the ratio of the Aid flow from UN agencies (US$) of 1971 in Middle East & North Africa (all income levels) to that in Middle East & North Africa (developing only)?
Your response must be concise. 1.01. What is the ratio of the Aid flow from UN agencies (US$) of 1972 in Middle East & North Africa (all income levels) to that in Middle East & North Africa (developing only)?
Give a very brief answer. 0.99. What is the ratio of the Aid flow from UN agencies (US$) in 1969 in Middle East & North Africa (all income levels) to that in Middle income?
Provide a succinct answer. 0.53. What is the ratio of the Aid flow from UN agencies (US$) in 1970 in Middle East & North Africa (all income levels) to that in Middle income?
Ensure brevity in your answer.  0.52. What is the ratio of the Aid flow from UN agencies (US$) in 1971 in Middle East & North Africa (all income levels) to that in Middle income?
Your response must be concise. 0.39. What is the ratio of the Aid flow from UN agencies (US$) of 1972 in Middle East & North Africa (all income levels) to that in Middle income?
Offer a very short reply. 0.39. What is the ratio of the Aid flow from UN agencies (US$) in 1969 in Middle East & North Africa (developing only) to that in Middle income?
Keep it short and to the point. 0.53. What is the ratio of the Aid flow from UN agencies (US$) of 1970 in Middle East & North Africa (developing only) to that in Middle income?
Offer a terse response. 0.51. What is the ratio of the Aid flow from UN agencies (US$) of 1971 in Middle East & North Africa (developing only) to that in Middle income?
Provide a short and direct response. 0.38. What is the ratio of the Aid flow from UN agencies (US$) of 1972 in Middle East & North Africa (developing only) to that in Middle income?
Ensure brevity in your answer.  0.4. What is the difference between the highest and the second highest Aid flow from UN agencies (US$) in 1969?
Keep it short and to the point. 8.02e+06. What is the difference between the highest and the second highest Aid flow from UN agencies (US$) in 1970?
Provide a succinct answer. 7.27e+06. What is the difference between the highest and the second highest Aid flow from UN agencies (US$) in 1971?
Provide a short and direct response. 1.05e+07. What is the difference between the highest and the second highest Aid flow from UN agencies (US$) of 1972?
Provide a short and direct response. 1.90e+07. What is the difference between the highest and the lowest Aid flow from UN agencies (US$) of 1969?
Offer a terse response. 4.99e+07. What is the difference between the highest and the lowest Aid flow from UN agencies (US$) in 1970?
Your response must be concise. 9.31e+07. What is the difference between the highest and the lowest Aid flow from UN agencies (US$) in 1971?
Provide a short and direct response. 1.22e+08. What is the difference between the highest and the lowest Aid flow from UN agencies (US$) in 1972?
Ensure brevity in your answer.  9.40e+07. 